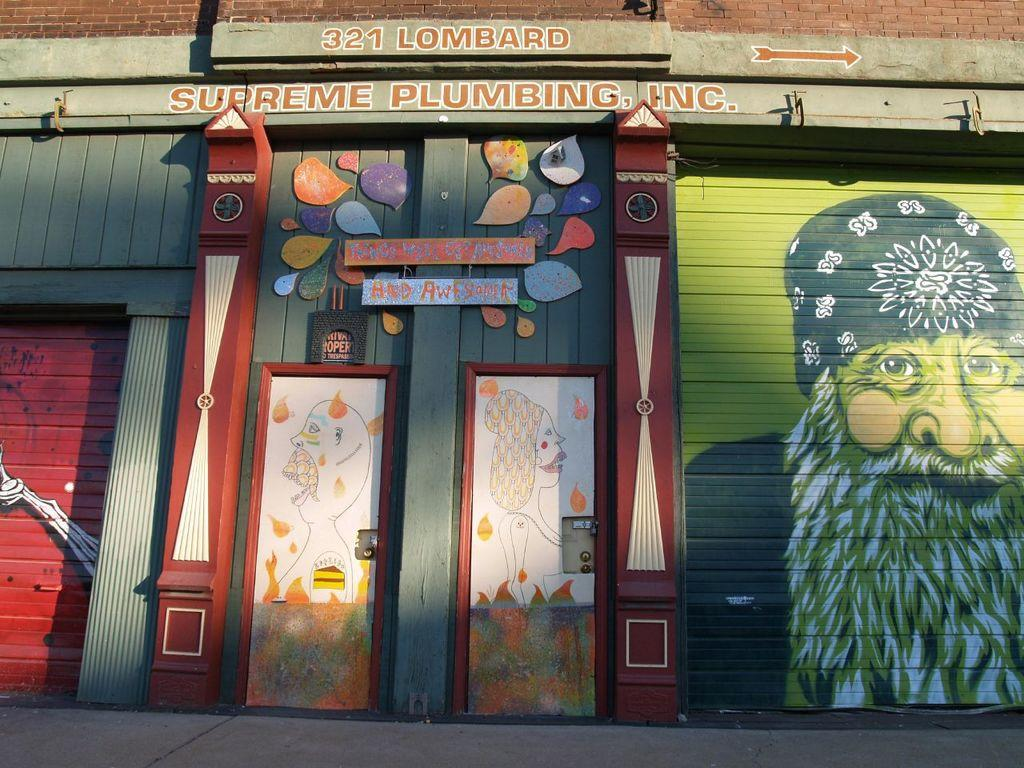What is the main subject of the image? The main subject of the image is a building. What can be seen on the building? There is art and text written on the building. What is located at the bottom of the image? There is a walkway at the bottom of the image. What type of cable is used to support the building in the image? There is no cable visible in the image, and the building does not appear to be supported by any cable. 